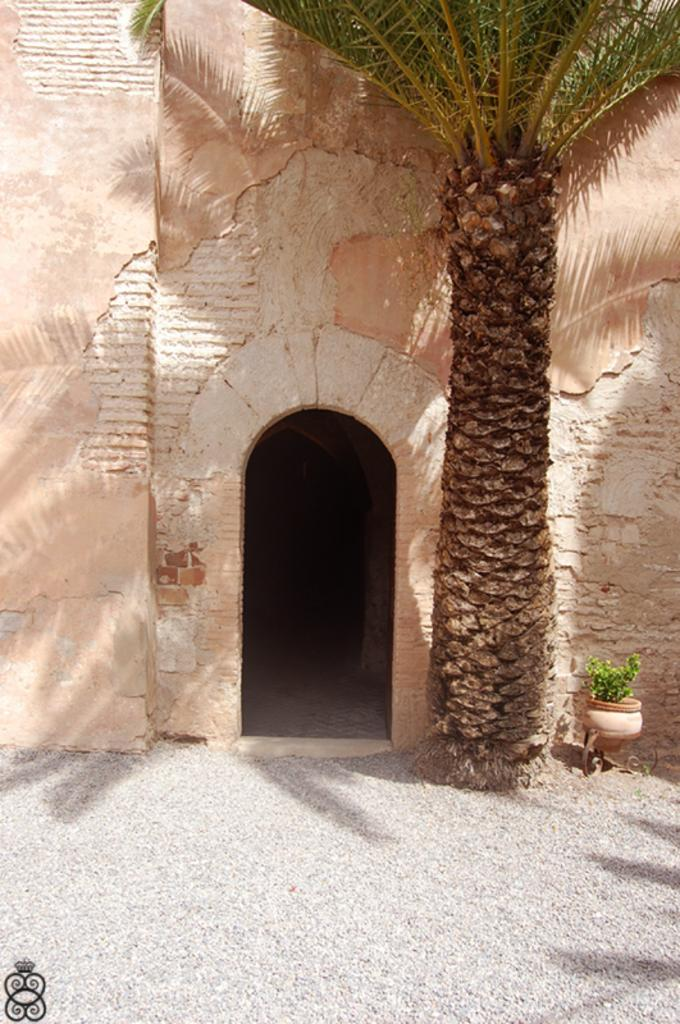What can be seen in the background of the image? There is a wall in the background of the image. What architectural feature is present in the image? There is an arch in the image. What type of plant is visible in the image? There is a tree in the image. What material is present at the bottom of the image? There are stones at the bottom of the image. Where is the pot located in the image? The pot is on the right side of the image. What type of flowers can be seen growing near the tree in the image? There are no flowers visible in the image; only a tree and an arch are present. Can you tell me how many dinosaurs are walking through the arch in the image? There are no dinosaurs present in the image; it features a tree, an arch, and a pot. 